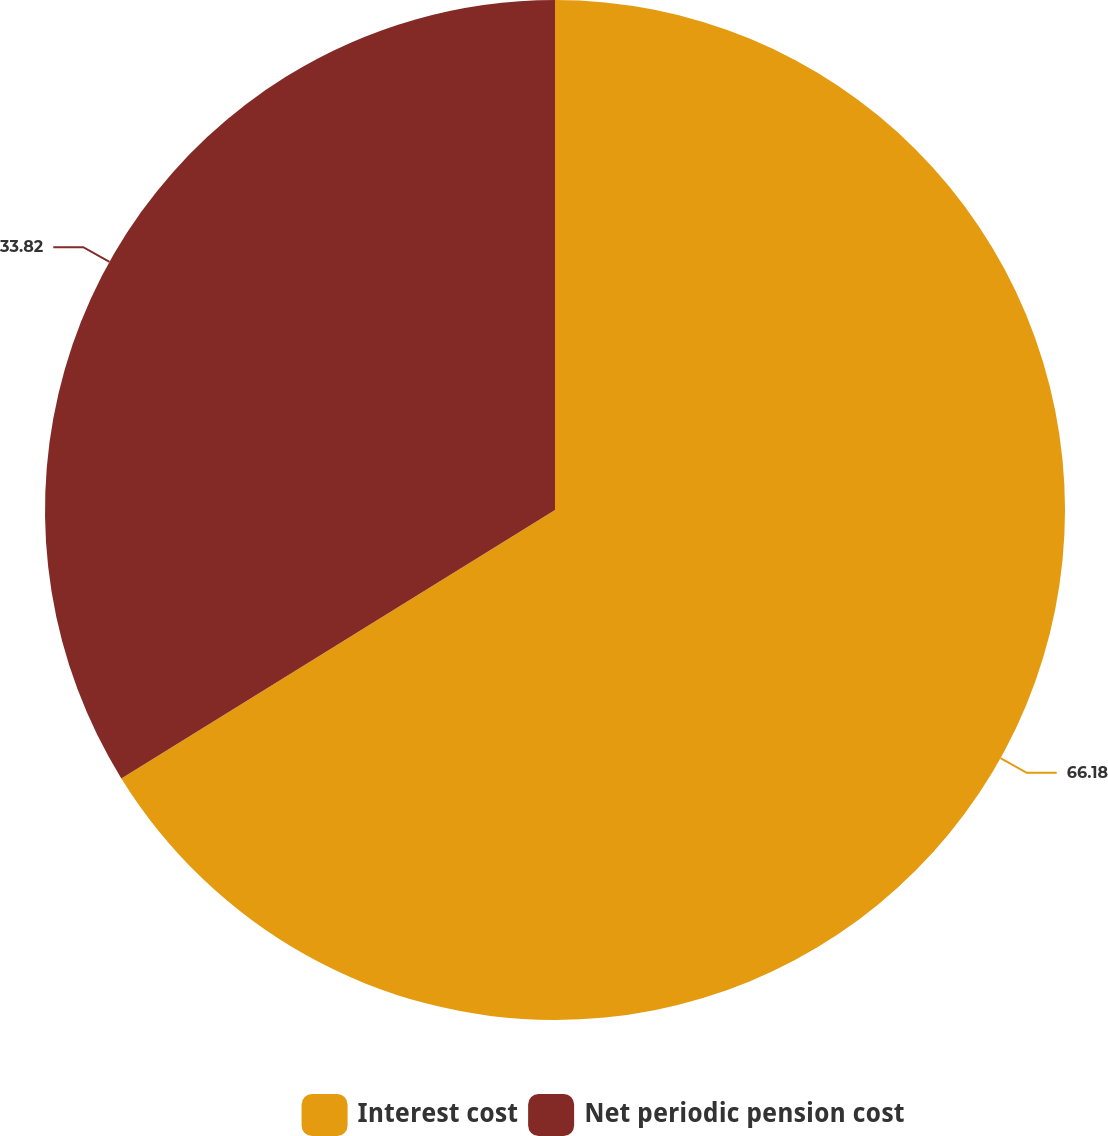Convert chart to OTSL. <chart><loc_0><loc_0><loc_500><loc_500><pie_chart><fcel>Interest cost<fcel>Net periodic pension cost<nl><fcel>66.18%<fcel>33.82%<nl></chart> 